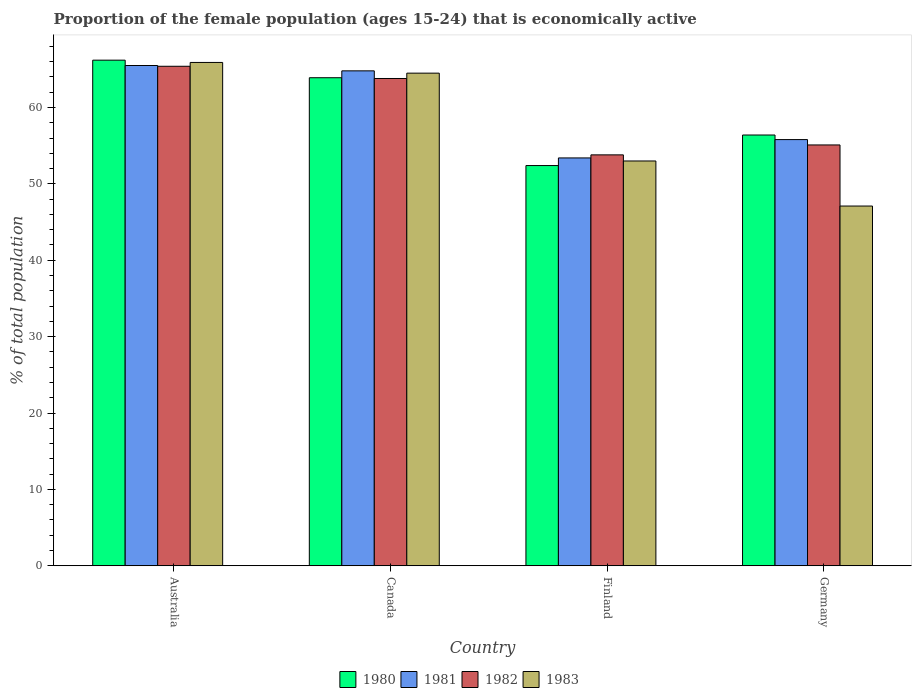How many different coloured bars are there?
Provide a short and direct response. 4. How many groups of bars are there?
Make the answer very short. 4. Are the number of bars per tick equal to the number of legend labels?
Your response must be concise. Yes. How many bars are there on the 2nd tick from the right?
Your answer should be compact. 4. What is the label of the 4th group of bars from the left?
Provide a short and direct response. Germany. What is the proportion of the female population that is economically active in 1983 in Finland?
Offer a terse response. 53. Across all countries, what is the maximum proportion of the female population that is economically active in 1982?
Provide a short and direct response. 65.4. Across all countries, what is the minimum proportion of the female population that is economically active in 1981?
Ensure brevity in your answer.  53.4. In which country was the proportion of the female population that is economically active in 1983 minimum?
Your response must be concise. Germany. What is the total proportion of the female population that is economically active in 1981 in the graph?
Provide a short and direct response. 239.5. What is the difference between the proportion of the female population that is economically active in 1983 in Australia and that in Finland?
Your answer should be very brief. 12.9. What is the difference between the proportion of the female population that is economically active in 1980 in Australia and the proportion of the female population that is economically active in 1983 in Finland?
Keep it short and to the point. 13.2. What is the average proportion of the female population that is economically active in 1983 per country?
Provide a short and direct response. 57.62. What is the difference between the proportion of the female population that is economically active of/in 1980 and proportion of the female population that is economically active of/in 1982 in Germany?
Offer a terse response. 1.3. In how many countries, is the proportion of the female population that is economically active in 1982 greater than 44 %?
Keep it short and to the point. 4. What is the ratio of the proportion of the female population that is economically active in 1980 in Finland to that in Germany?
Provide a succinct answer. 0.93. Is the difference between the proportion of the female population that is economically active in 1980 in Australia and Canada greater than the difference between the proportion of the female population that is economically active in 1982 in Australia and Canada?
Make the answer very short. Yes. What is the difference between the highest and the second highest proportion of the female population that is economically active in 1981?
Provide a short and direct response. -0.7. What is the difference between the highest and the lowest proportion of the female population that is economically active in 1983?
Provide a short and direct response. 18.8. Is the sum of the proportion of the female population that is economically active in 1980 in Australia and Germany greater than the maximum proportion of the female population that is economically active in 1981 across all countries?
Offer a terse response. Yes. Is it the case that in every country, the sum of the proportion of the female population that is economically active in 1980 and proportion of the female population that is economically active in 1982 is greater than the sum of proportion of the female population that is economically active in 1983 and proportion of the female population that is economically active in 1981?
Keep it short and to the point. No. What does the 1st bar from the left in Australia represents?
Give a very brief answer. 1980. Is it the case that in every country, the sum of the proportion of the female population that is economically active in 1981 and proportion of the female population that is economically active in 1982 is greater than the proportion of the female population that is economically active in 1980?
Offer a terse response. Yes. Are all the bars in the graph horizontal?
Offer a terse response. No. What is the difference between two consecutive major ticks on the Y-axis?
Give a very brief answer. 10. Are the values on the major ticks of Y-axis written in scientific E-notation?
Give a very brief answer. No. Does the graph contain grids?
Your answer should be very brief. No. Where does the legend appear in the graph?
Offer a terse response. Bottom center. How are the legend labels stacked?
Keep it short and to the point. Horizontal. What is the title of the graph?
Offer a very short reply. Proportion of the female population (ages 15-24) that is economically active. Does "1962" appear as one of the legend labels in the graph?
Offer a terse response. No. What is the label or title of the Y-axis?
Keep it short and to the point. % of total population. What is the % of total population of 1980 in Australia?
Keep it short and to the point. 66.2. What is the % of total population of 1981 in Australia?
Make the answer very short. 65.5. What is the % of total population of 1982 in Australia?
Keep it short and to the point. 65.4. What is the % of total population of 1983 in Australia?
Your answer should be compact. 65.9. What is the % of total population in 1980 in Canada?
Keep it short and to the point. 63.9. What is the % of total population of 1981 in Canada?
Give a very brief answer. 64.8. What is the % of total population of 1982 in Canada?
Give a very brief answer. 63.8. What is the % of total population in 1983 in Canada?
Offer a very short reply. 64.5. What is the % of total population of 1980 in Finland?
Your response must be concise. 52.4. What is the % of total population of 1981 in Finland?
Offer a terse response. 53.4. What is the % of total population in 1982 in Finland?
Provide a succinct answer. 53.8. What is the % of total population of 1980 in Germany?
Ensure brevity in your answer.  56.4. What is the % of total population of 1981 in Germany?
Offer a very short reply. 55.8. What is the % of total population in 1982 in Germany?
Provide a short and direct response. 55.1. What is the % of total population of 1983 in Germany?
Your response must be concise. 47.1. Across all countries, what is the maximum % of total population in 1980?
Give a very brief answer. 66.2. Across all countries, what is the maximum % of total population in 1981?
Your response must be concise. 65.5. Across all countries, what is the maximum % of total population of 1982?
Offer a terse response. 65.4. Across all countries, what is the maximum % of total population of 1983?
Provide a short and direct response. 65.9. Across all countries, what is the minimum % of total population of 1980?
Provide a succinct answer. 52.4. Across all countries, what is the minimum % of total population of 1981?
Offer a terse response. 53.4. Across all countries, what is the minimum % of total population in 1982?
Make the answer very short. 53.8. Across all countries, what is the minimum % of total population of 1983?
Give a very brief answer. 47.1. What is the total % of total population of 1980 in the graph?
Your answer should be very brief. 238.9. What is the total % of total population in 1981 in the graph?
Provide a succinct answer. 239.5. What is the total % of total population of 1982 in the graph?
Provide a short and direct response. 238.1. What is the total % of total population of 1983 in the graph?
Provide a succinct answer. 230.5. What is the difference between the % of total population of 1981 in Australia and that in Canada?
Offer a very short reply. 0.7. What is the difference between the % of total population in 1982 in Australia and that in Canada?
Provide a succinct answer. 1.6. What is the difference between the % of total population of 1980 in Australia and that in Finland?
Offer a terse response. 13.8. What is the difference between the % of total population in 1982 in Australia and that in Finland?
Make the answer very short. 11.6. What is the difference between the % of total population in 1983 in Australia and that in Finland?
Your response must be concise. 12.9. What is the difference between the % of total population of 1980 in Australia and that in Germany?
Your answer should be very brief. 9.8. What is the difference between the % of total population of 1983 in Australia and that in Germany?
Ensure brevity in your answer.  18.8. What is the difference between the % of total population in 1982 in Canada and that in Germany?
Make the answer very short. 8.7. What is the difference between the % of total population in 1980 in Finland and that in Germany?
Ensure brevity in your answer.  -4. What is the difference between the % of total population in 1980 in Australia and the % of total population in 1981 in Finland?
Provide a short and direct response. 12.8. What is the difference between the % of total population of 1982 in Australia and the % of total population of 1983 in Finland?
Your answer should be compact. 12.4. What is the difference between the % of total population in 1981 in Australia and the % of total population in 1982 in Germany?
Make the answer very short. 10.4. What is the difference between the % of total population of 1982 in Australia and the % of total population of 1983 in Germany?
Offer a terse response. 18.3. What is the difference between the % of total population in 1980 in Canada and the % of total population in 1981 in Finland?
Ensure brevity in your answer.  10.5. What is the difference between the % of total population of 1980 in Canada and the % of total population of 1982 in Finland?
Your answer should be very brief. 10.1. What is the difference between the % of total population in 1980 in Canada and the % of total population in 1983 in Finland?
Provide a succinct answer. 10.9. What is the difference between the % of total population of 1981 in Canada and the % of total population of 1983 in Finland?
Make the answer very short. 11.8. What is the difference between the % of total population in 1982 in Canada and the % of total population in 1983 in Finland?
Give a very brief answer. 10.8. What is the difference between the % of total population in 1981 in Canada and the % of total population in 1982 in Germany?
Your answer should be compact. 9.7. What is the difference between the % of total population of 1981 in Canada and the % of total population of 1983 in Germany?
Your answer should be very brief. 17.7. What is the difference between the % of total population of 1982 in Canada and the % of total population of 1983 in Germany?
Make the answer very short. 16.7. What is the difference between the % of total population of 1980 in Finland and the % of total population of 1981 in Germany?
Make the answer very short. -3.4. What is the difference between the % of total population in 1980 in Finland and the % of total population in 1983 in Germany?
Your answer should be compact. 5.3. What is the difference between the % of total population in 1981 in Finland and the % of total population in 1982 in Germany?
Your response must be concise. -1.7. What is the difference between the % of total population of 1981 in Finland and the % of total population of 1983 in Germany?
Ensure brevity in your answer.  6.3. What is the difference between the % of total population of 1982 in Finland and the % of total population of 1983 in Germany?
Your answer should be very brief. 6.7. What is the average % of total population in 1980 per country?
Your answer should be compact. 59.73. What is the average % of total population in 1981 per country?
Offer a very short reply. 59.88. What is the average % of total population of 1982 per country?
Ensure brevity in your answer.  59.52. What is the average % of total population of 1983 per country?
Keep it short and to the point. 57.62. What is the difference between the % of total population in 1980 and % of total population in 1981 in Australia?
Offer a very short reply. 0.7. What is the difference between the % of total population in 1980 and % of total population in 1982 in Australia?
Your response must be concise. 0.8. What is the difference between the % of total population in 1980 and % of total population in 1983 in Australia?
Your response must be concise. 0.3. What is the difference between the % of total population of 1981 and % of total population of 1982 in Australia?
Your response must be concise. 0.1. What is the difference between the % of total population in 1981 and % of total population in 1983 in Australia?
Give a very brief answer. -0.4. What is the difference between the % of total population in 1982 and % of total population in 1983 in Australia?
Your response must be concise. -0.5. What is the difference between the % of total population of 1980 and % of total population of 1981 in Canada?
Provide a succinct answer. -0.9. What is the difference between the % of total population of 1981 and % of total population of 1983 in Canada?
Your response must be concise. 0.3. What is the difference between the % of total population of 1980 and % of total population of 1982 in Finland?
Make the answer very short. -1.4. What is the difference between the % of total population of 1981 and % of total population of 1983 in Finland?
Keep it short and to the point. 0.4. What is the difference between the % of total population of 1980 and % of total population of 1981 in Germany?
Keep it short and to the point. 0.6. What is the difference between the % of total population of 1982 and % of total population of 1983 in Germany?
Make the answer very short. 8. What is the ratio of the % of total population in 1980 in Australia to that in Canada?
Your answer should be very brief. 1.04. What is the ratio of the % of total population in 1981 in Australia to that in Canada?
Your answer should be compact. 1.01. What is the ratio of the % of total population of 1982 in Australia to that in Canada?
Make the answer very short. 1.03. What is the ratio of the % of total population of 1983 in Australia to that in Canada?
Your response must be concise. 1.02. What is the ratio of the % of total population in 1980 in Australia to that in Finland?
Offer a terse response. 1.26. What is the ratio of the % of total population of 1981 in Australia to that in Finland?
Give a very brief answer. 1.23. What is the ratio of the % of total population of 1982 in Australia to that in Finland?
Ensure brevity in your answer.  1.22. What is the ratio of the % of total population of 1983 in Australia to that in Finland?
Give a very brief answer. 1.24. What is the ratio of the % of total population of 1980 in Australia to that in Germany?
Keep it short and to the point. 1.17. What is the ratio of the % of total population of 1981 in Australia to that in Germany?
Provide a succinct answer. 1.17. What is the ratio of the % of total population of 1982 in Australia to that in Germany?
Provide a short and direct response. 1.19. What is the ratio of the % of total population of 1983 in Australia to that in Germany?
Your answer should be compact. 1.4. What is the ratio of the % of total population of 1980 in Canada to that in Finland?
Your answer should be compact. 1.22. What is the ratio of the % of total population in 1981 in Canada to that in Finland?
Your response must be concise. 1.21. What is the ratio of the % of total population of 1982 in Canada to that in Finland?
Make the answer very short. 1.19. What is the ratio of the % of total population in 1983 in Canada to that in Finland?
Give a very brief answer. 1.22. What is the ratio of the % of total population in 1980 in Canada to that in Germany?
Give a very brief answer. 1.13. What is the ratio of the % of total population in 1981 in Canada to that in Germany?
Offer a very short reply. 1.16. What is the ratio of the % of total population of 1982 in Canada to that in Germany?
Ensure brevity in your answer.  1.16. What is the ratio of the % of total population in 1983 in Canada to that in Germany?
Make the answer very short. 1.37. What is the ratio of the % of total population of 1980 in Finland to that in Germany?
Your answer should be compact. 0.93. What is the ratio of the % of total population of 1981 in Finland to that in Germany?
Give a very brief answer. 0.96. What is the ratio of the % of total population of 1982 in Finland to that in Germany?
Provide a short and direct response. 0.98. What is the ratio of the % of total population in 1983 in Finland to that in Germany?
Keep it short and to the point. 1.13. What is the difference between the highest and the second highest % of total population of 1982?
Offer a terse response. 1.6. What is the difference between the highest and the second highest % of total population in 1983?
Keep it short and to the point. 1.4. What is the difference between the highest and the lowest % of total population in 1982?
Give a very brief answer. 11.6. What is the difference between the highest and the lowest % of total population of 1983?
Make the answer very short. 18.8. 